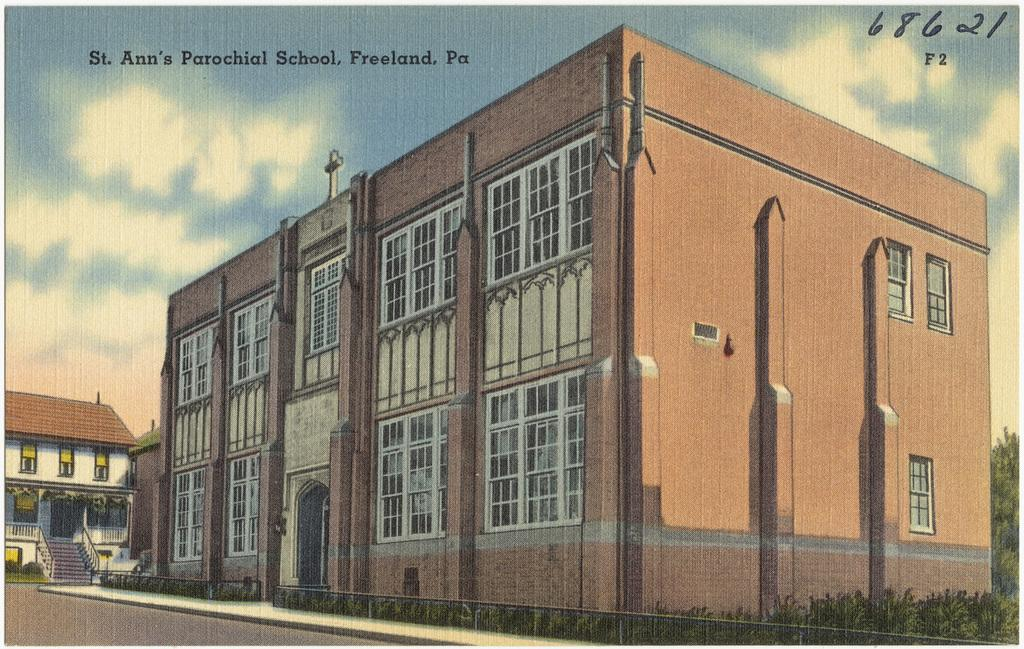<image>
Give a short and clear explanation of the subsequent image. A painting of St. Ann's Parochial School which is located in Freeland, Pennsylvania. 